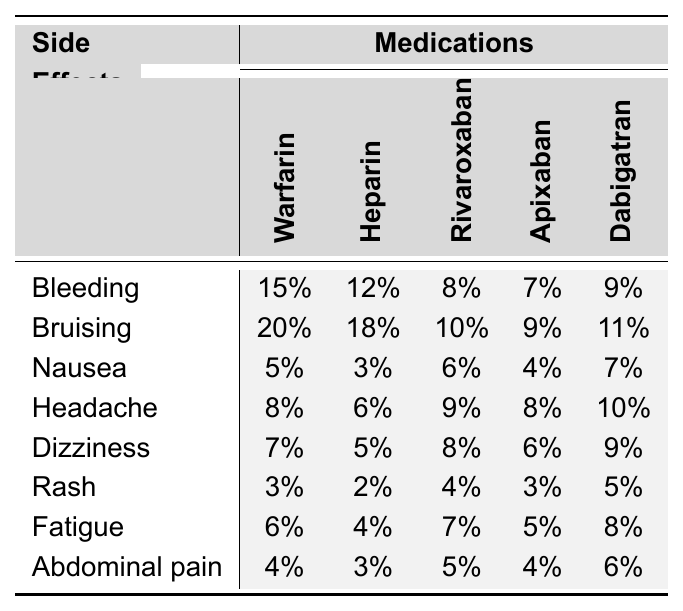What is the frequency of bleeding as a side effect for Warfarin? According to the table, the frequency of bleeding for Warfarin is listed directly as 15%.
Answer: 15% Which anticoagulant has the highest frequency of bruising? By comparing the values in the bruising row, Heparin has the highest frequency at 18%.
Answer: Heparin What side effect has the lowest frequency across all medications? Looking at the frequencies for each side effect, nausea has the lowest frequency at 3% (for Heparin).
Answer: Nausea What is the average frequency of headache as a side effect? The frequencies of headache for each medication are: 8%, 6%, 9%, 8%, and 10%. Average = (8 + 6 + 9 + 8 + 10) / 5 = 41 / 5 = 8.2%.
Answer: 8.2% Is the frequency of abdominal pain higher for Apixaban than for Rivaroxaban? The frequency for Abdominal Pain is 4% for Apixaban and 5% for Rivaroxaban. Since 4% is less than 5%, the statement is false.
Answer: No Which anticoagulant has the second highest frequency of fatigue, and what is that frequency? Looking at the fatigue row, the frequencies are: Warfarin (6%), Heparin (4%), Rivaroxaban (7%), Apixaban (5%), Dabigatran (8%). Rivaroxaban has the highest (7%), followed by Dabigatran (8%), thus the second highest is Dabigatran at 8%.
Answer: Dabigatran, 8% Which two medications have the same frequency of dizziness? The table shows that both Apixaban and Rivaroxaban have a frequency of 6% for dizziness, indicating they are the same.
Answer: Apixaban and Rivaroxaban Calculate the difference in frequency of rash between Warfarin and Dabigatran. The frequency of rash for Warfarin is 3% and for Dabigatran it is 5%. The difference is 5% - 3% = 2%.
Answer: 2% Is the frequency of side effects for Heparin generally higher than for Warfarin? By comparing the frequencies side by side, most are higher for Heparin (e.g., bruising 18% vs. 15%), but not all (e.g., fatigue 4% vs. 6%). Thus, it's not true for every side effect.
Answer: No What is the total frequency of bruising for all medications combined? Adding the frequencies of bruising: 20% (Warfarin) + 18% (Heparin) + 10% (Rivaroxaban) + 9% (Apixaban) + 11% (Dabigatran) gives a total of 68%.
Answer: 68% 